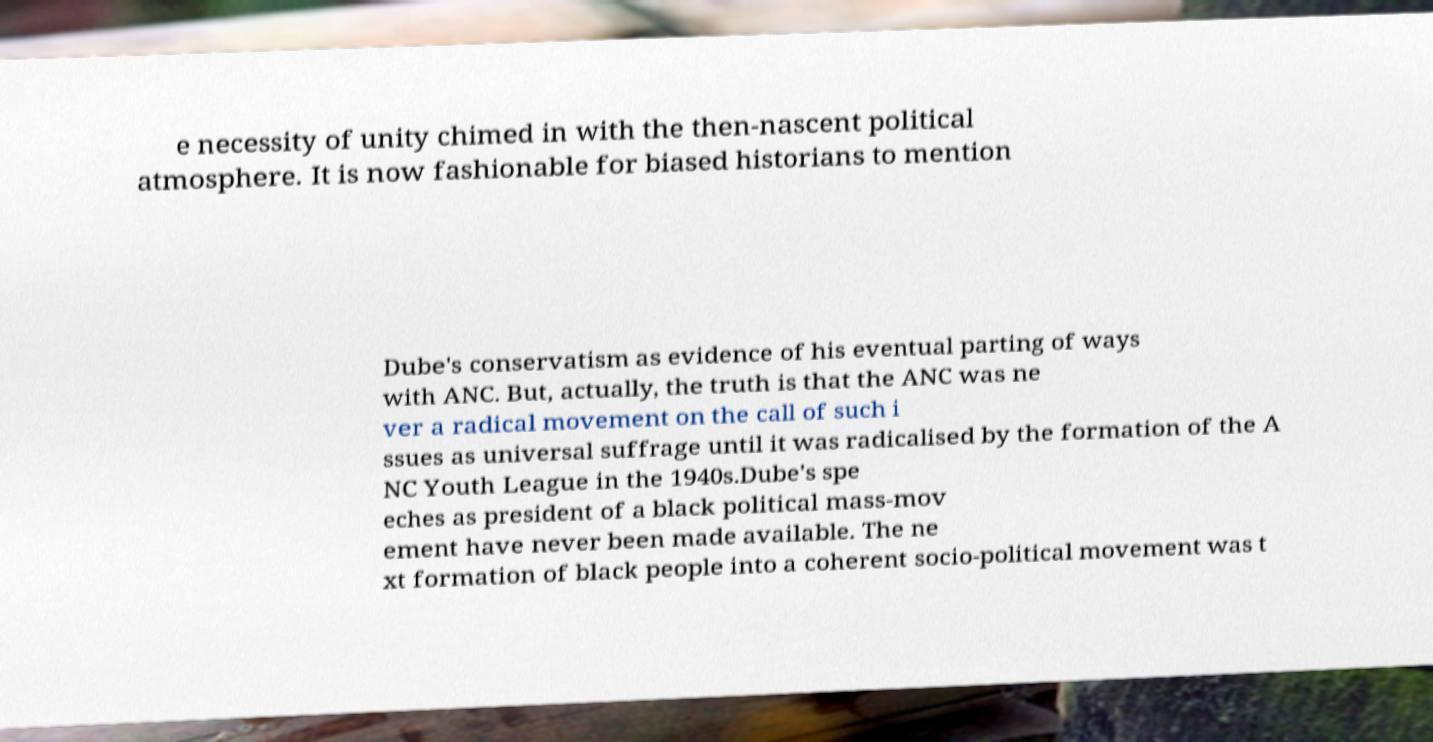Can you read and provide the text displayed in the image?This photo seems to have some interesting text. Can you extract and type it out for me? e necessity of unity chimed in with the then-nascent political atmosphere. It is now fashionable for biased historians to mention Dube's conservatism as evidence of his eventual parting of ways with ANC. But, actually, the truth is that the ANC was ne ver a radical movement on the call of such i ssues as universal suffrage until it was radicalised by the formation of the A NC Youth League in the 1940s.Dube's spe eches as president of a black political mass-mov ement have never been made available. The ne xt formation of black people into a coherent socio-political movement was t 